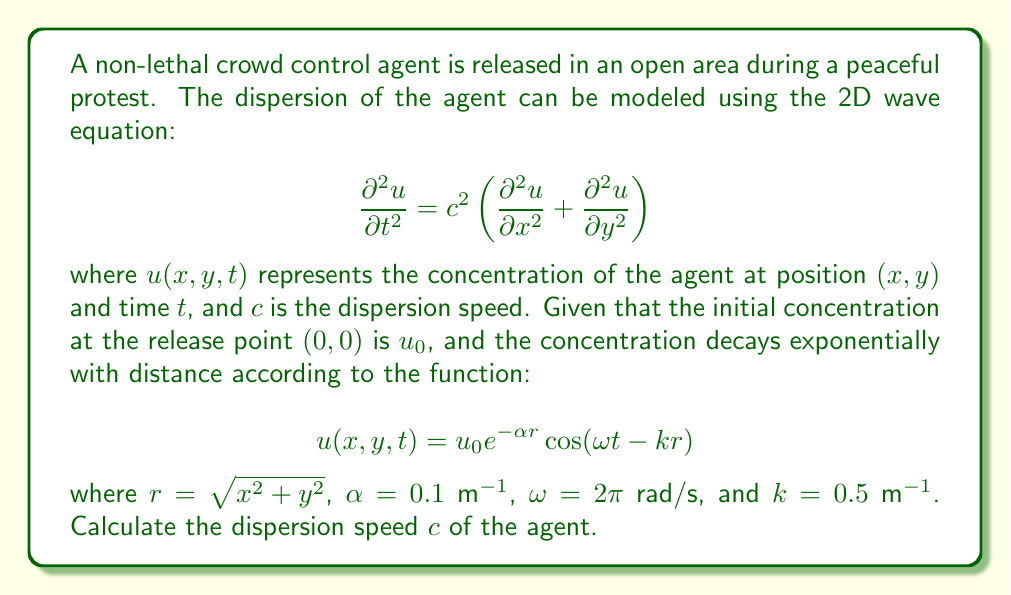Could you help me with this problem? To solve this problem, we need to follow these steps:

1) The given solution $u(x,y,t)$ must satisfy the 2D wave equation. Let's substitute it into the equation and solve for $c$.

2) First, let's calculate the necessary partial derivatives:

   $$\frac{\partial u}{\partial t} = -u_0 \omega e^{-\alpha r} \sin(\omega t - kr)$$
   $$\frac{\partial^2 u}{\partial t^2} = -u_0 \omega^2 e^{-\alpha r} \cos(\omega t - kr)$$

   $$\frac{\partial u}{\partial x} = u_0 e^{-\alpha r} \left(-\alpha \frac{x}{r} \cos(\omega t - kr) + k \frac{x}{r} \sin(\omega t - kr)\right)$$
   $$\frac{\partial^2 u}{\partial x^2} = u_0 e^{-\alpha r} \left[(\alpha^2 \frac{x^2}{r^2} - \alpha \frac{y^2}{r^3} - k^2 \frac{x^2}{r^2}) \cos(\omega t - kr) + (-2\alpha k \frac{x^2}{r^2} + k \frac{y^2}{r^3}) \sin(\omega t - kr)\right]$$

   The expression for $\frac{\partial^2 u}{\partial y^2}$ is similar, with $x$ and $y$ interchanged.

3) Substituting these into the wave equation:

   $$-\omega^2 = c^2 \left[(\alpha^2 - k^2) - \frac{\alpha}{r}\right]$$

4) For this equation to hold for all $r$, we must have:

   $$\omega^2 = c^2 (k^2 - \alpha^2)$$

5) Solving for $c$:

   $$c = \frac{\omega}{\sqrt{k^2 - \alpha^2}}$$

6) Substituting the given values:

   $$c = \frac{2\pi}{\sqrt{0.5^2 - 0.1^2}} \approx 13.42 \text{ m/s}$$
Answer: $c \approx 13.42 \text{ m/s}$ 